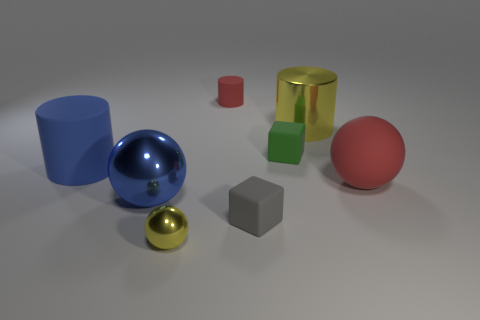Is the number of cubes that are in front of the small ball the same as the number of tiny cyan matte cubes?
Provide a short and direct response. Yes. There is a object that is the same color as the large metallic sphere; what is its material?
Your answer should be compact. Rubber. There is a gray thing; is its size the same as the rubber cylinder to the right of the tiny ball?
Provide a short and direct response. Yes. How many other objects are the same color as the small cylinder?
Make the answer very short. 1. What number of other objects are there of the same shape as the small yellow object?
Your response must be concise. 2. Do the blue metal ball and the red cylinder have the same size?
Ensure brevity in your answer.  No. Are there any large brown things?
Ensure brevity in your answer.  No. Is there a big red sphere that has the same material as the small gray block?
Your answer should be compact. Yes. There is a red object that is the same size as the gray matte thing; what is it made of?
Your response must be concise. Rubber. What number of small blue matte things are the same shape as the green matte object?
Provide a short and direct response. 0. 